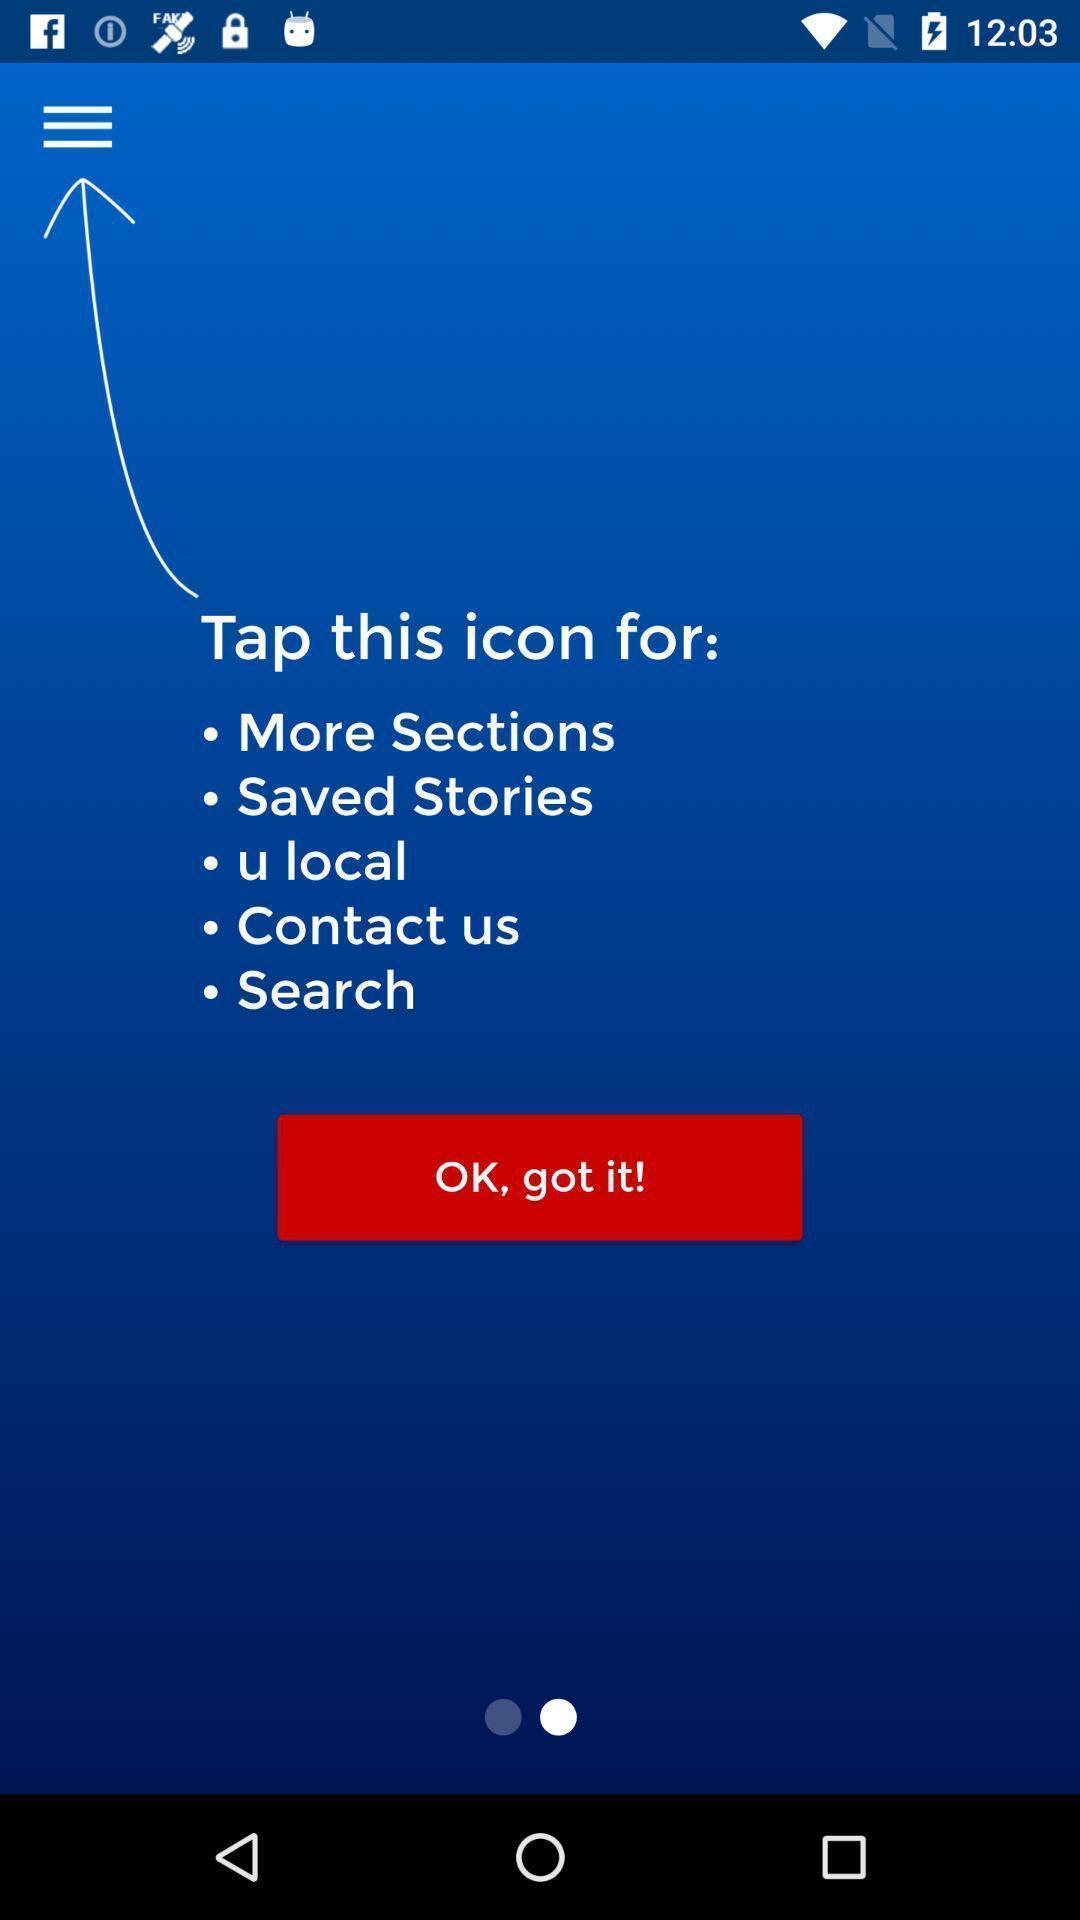Tell me about the visual elements in this screen capture. Screen displaying the guide to use an app. 